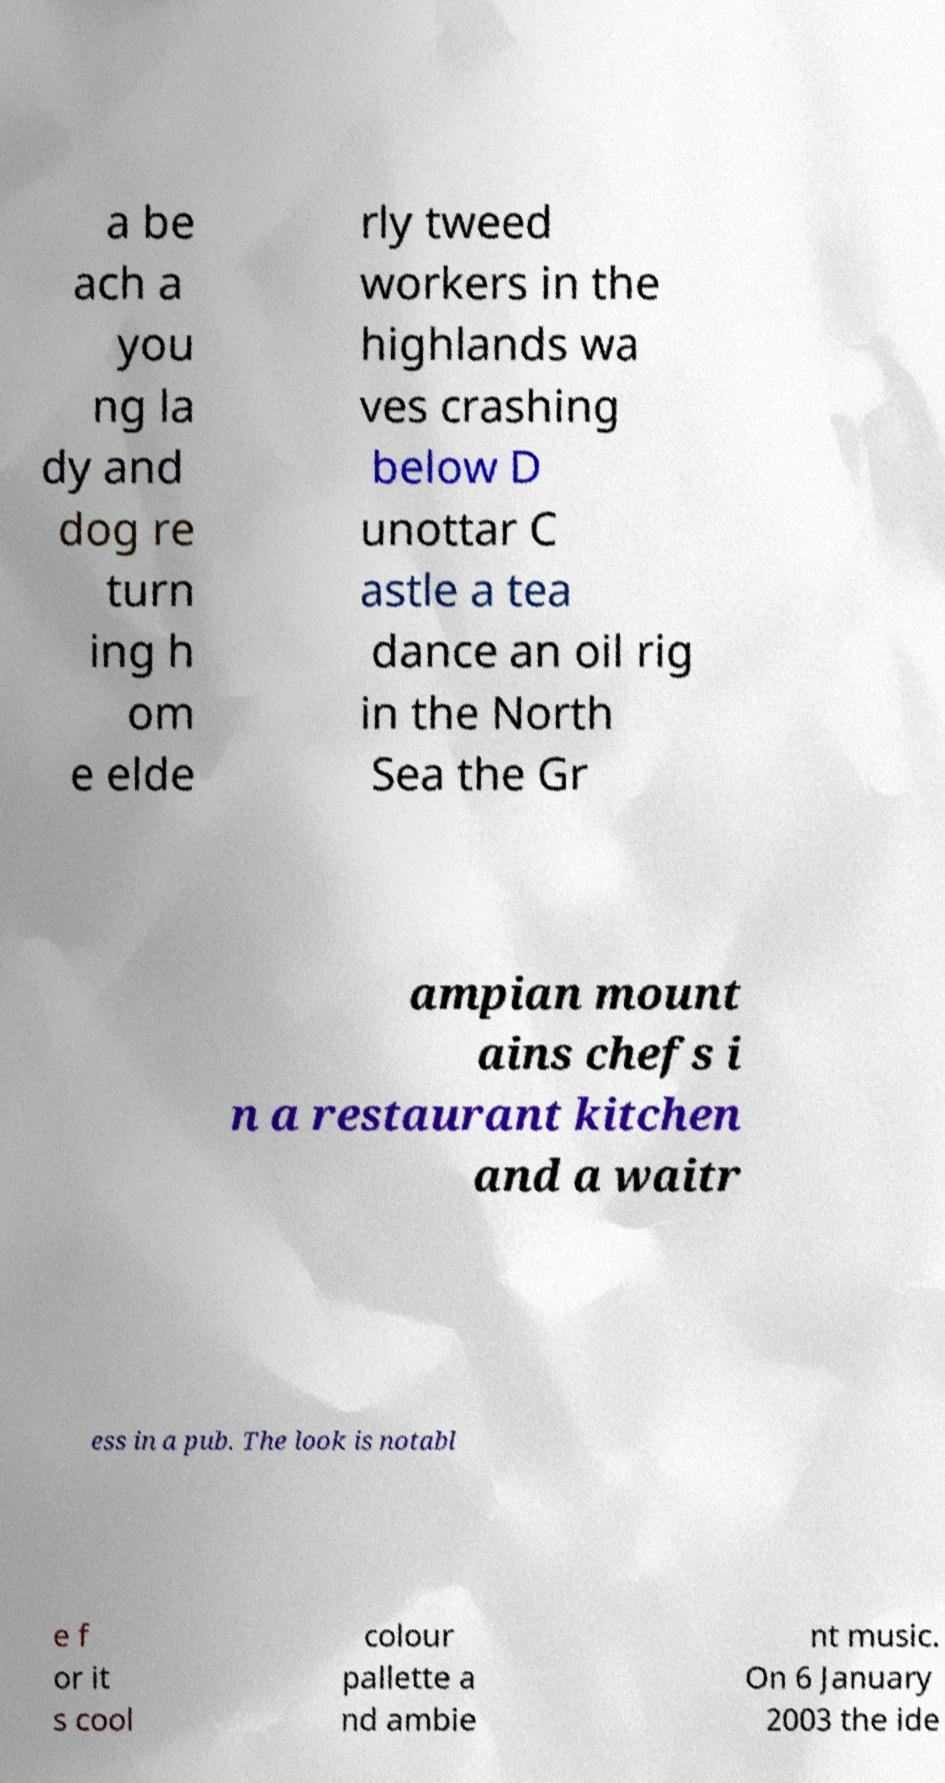There's text embedded in this image that I need extracted. Can you transcribe it verbatim? a be ach a you ng la dy and dog re turn ing h om e elde rly tweed workers in the highlands wa ves crashing below D unottar C astle a tea dance an oil rig in the North Sea the Gr ampian mount ains chefs i n a restaurant kitchen and a waitr ess in a pub. The look is notabl e f or it s cool colour pallette a nd ambie nt music. On 6 January 2003 the ide 